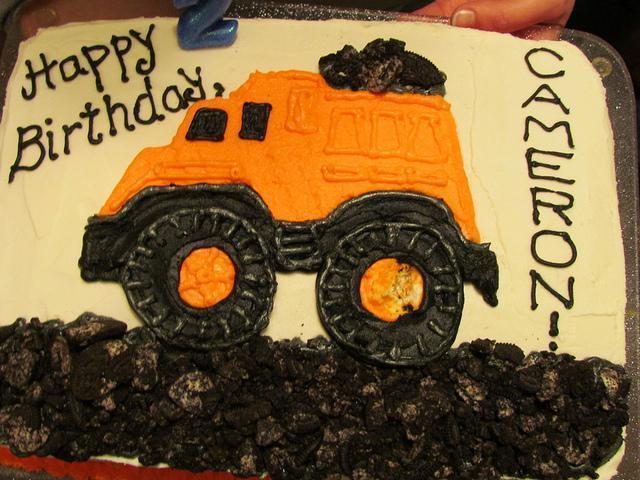How many people can be seen?
Give a very brief answer. 1. 